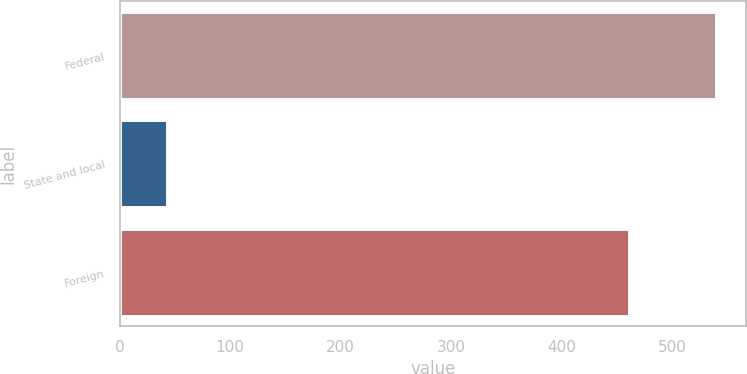Convert chart to OTSL. <chart><loc_0><loc_0><loc_500><loc_500><bar_chart><fcel>Federal<fcel>State and local<fcel>Foreign<nl><fcel>540<fcel>43<fcel>461<nl></chart> 